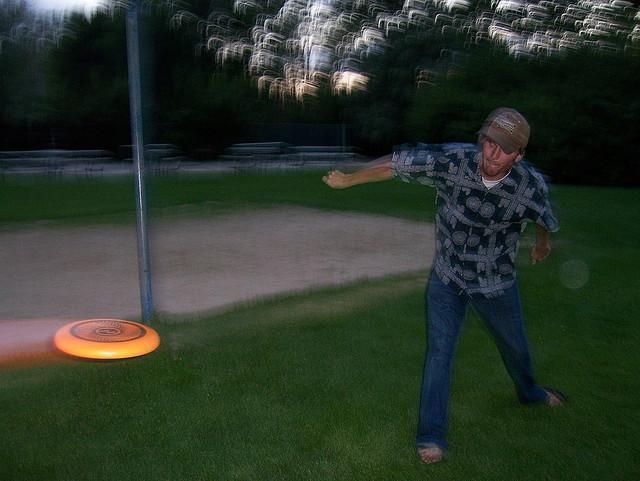In which type space does this man spin his frisbee?
Indicate the correct response by choosing from the four available options to answer the question.
Options: Beach, jail, urban, park. Park. 